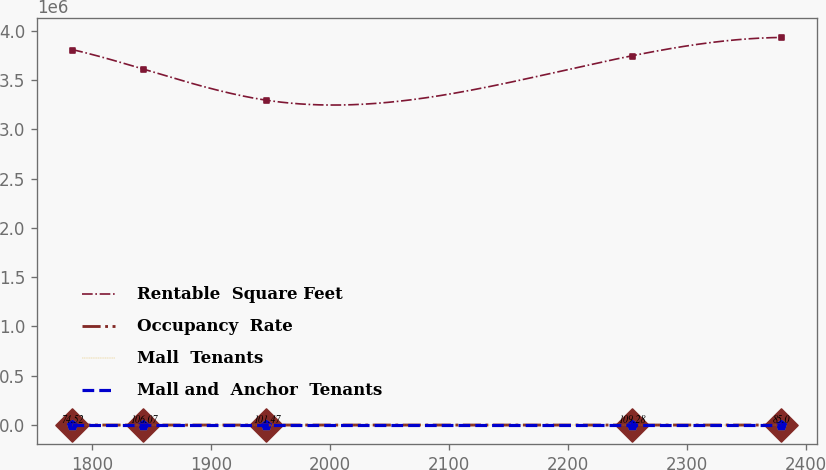Convert chart. <chart><loc_0><loc_0><loc_500><loc_500><line_chart><ecel><fcel>Rentable  Square Feet<fcel>Occupancy  Rate<fcel>Mall  Tenants<fcel>Mall and  Anchor  Tenants<nl><fcel>1783.39<fcel>3.8084e+06<fcel>74.52<fcel>49.99<fcel>22.45<nl><fcel>1842.95<fcel>3.61051e+06<fcel>106.07<fcel>44.84<fcel>25.82<nl><fcel>1946.39<fcel>3.29494e+06<fcel>101.47<fcel>46.98<fcel>27.3<nl><fcel>2253.31<fcel>3.74475e+06<fcel>109.28<fcel>31.54<fcel>18.43<nl><fcel>2378.98<fcel>3.93146e+06<fcel>85<fcel>28.62<fcel>19.78<nl></chart> 